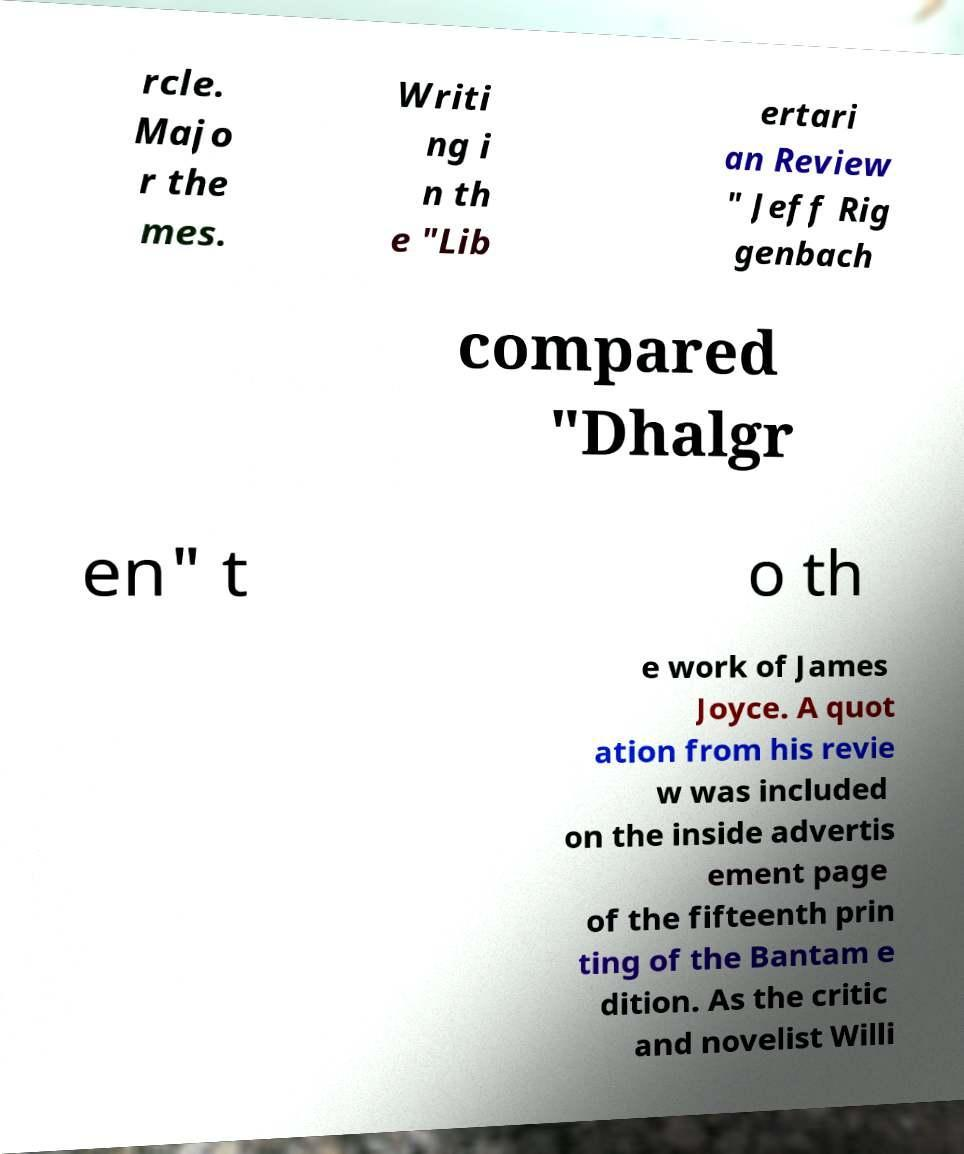Could you extract and type out the text from this image? rcle. Majo r the mes. Writi ng i n th e "Lib ertari an Review " Jeff Rig genbach compared "Dhalgr en" t o th e work of James Joyce. A quot ation from his revie w was included on the inside advertis ement page of the fifteenth prin ting of the Bantam e dition. As the critic and novelist Willi 